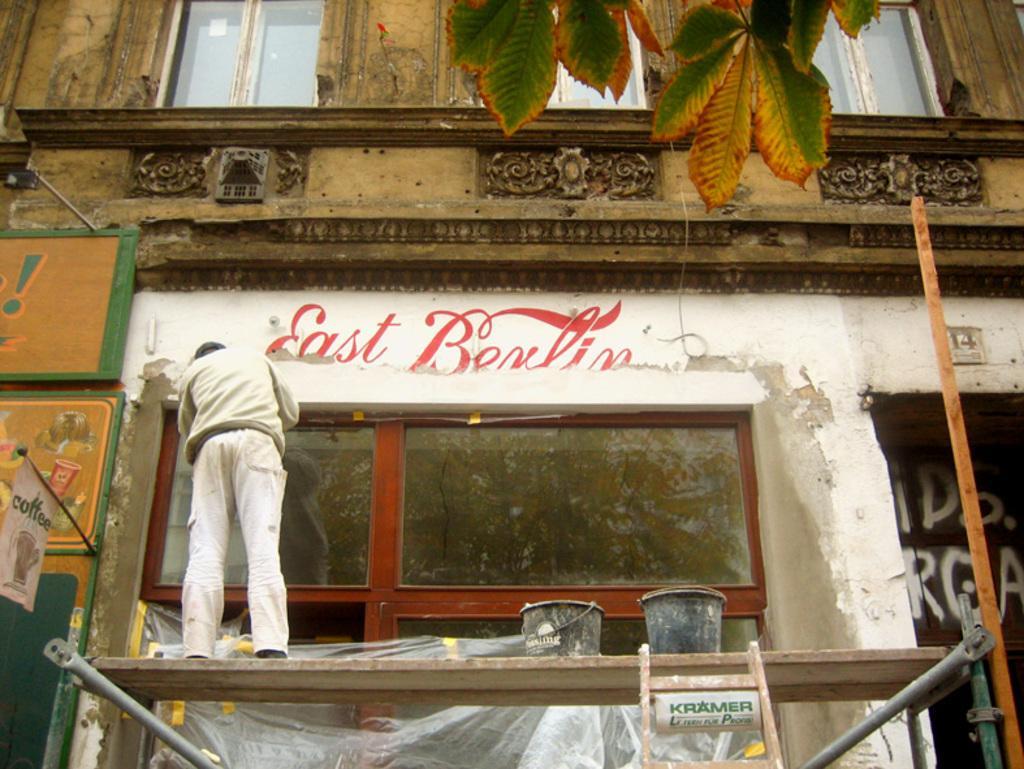How would you summarize this image in a sentence or two? In this image a person is standing on a metal object having two buckets. Bottom of the image there is a ladder. Background there is a building having few windows. Top of the image there are few leaves. Left side there is a banner attached to the metal rod which is attached to the wall. 